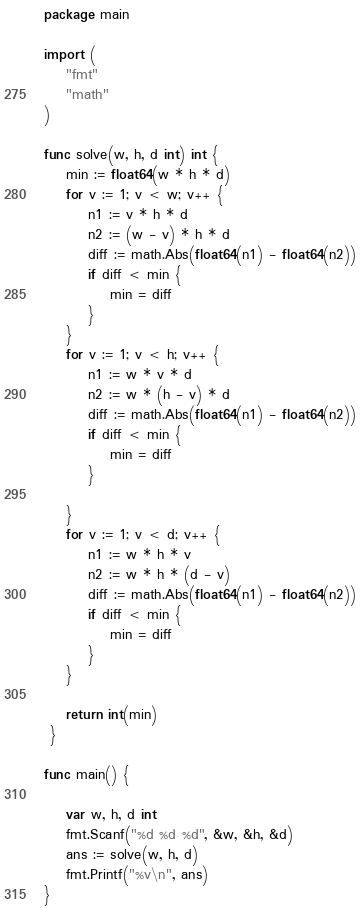Convert code to text. <code><loc_0><loc_0><loc_500><loc_500><_Go_>package main

import (
    "fmt"
    "math"
)

func solve(w, h, d int) int {
    min := float64(w * h * d)
    for v := 1; v < w; v++ {
        n1 := v * h * d
        n2 := (w - v) * h * d
        diff := math.Abs(float64(n1) - float64(n2))
        if diff < min {
            min = diff
        }
    }
    for v := 1; v < h; v++ {
        n1 := w * v * d
        n2 := w * (h - v) * d
        diff := math.Abs(float64(n1) - float64(n2))
        if diff < min {
            min = diff
        }

    }
    for v := 1; v < d; v++ {
        n1 := w * h * v
        n2 := w * h * (d - v)
        diff := math.Abs(float64(n1) - float64(n2))
        if diff < min {
            min = diff
        }
    }

    return int(min)
 }

func main() {

    var w, h, d int
    fmt.Scanf("%d %d %d", &w, &h, &d)
    ans := solve(w, h, d)
    fmt.Printf("%v\n", ans)
}</code> 